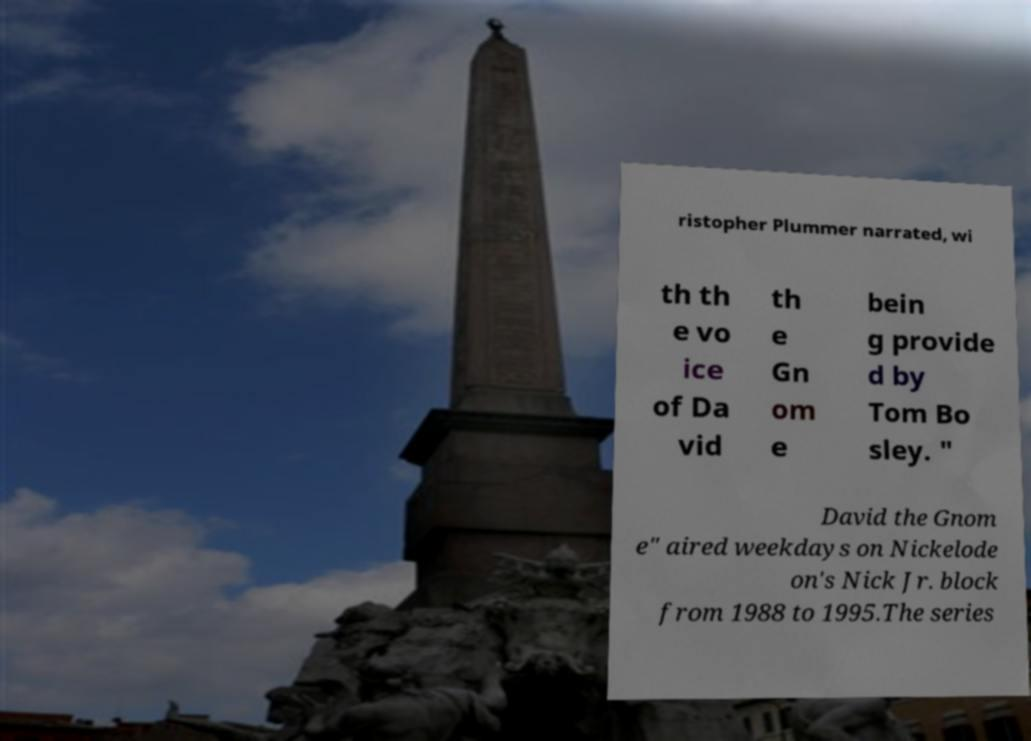For documentation purposes, I need the text within this image transcribed. Could you provide that? ristopher Plummer narrated, wi th th e vo ice of Da vid th e Gn om e bein g provide d by Tom Bo sley. " David the Gnom e" aired weekdays on Nickelode on's Nick Jr. block from 1988 to 1995.The series 